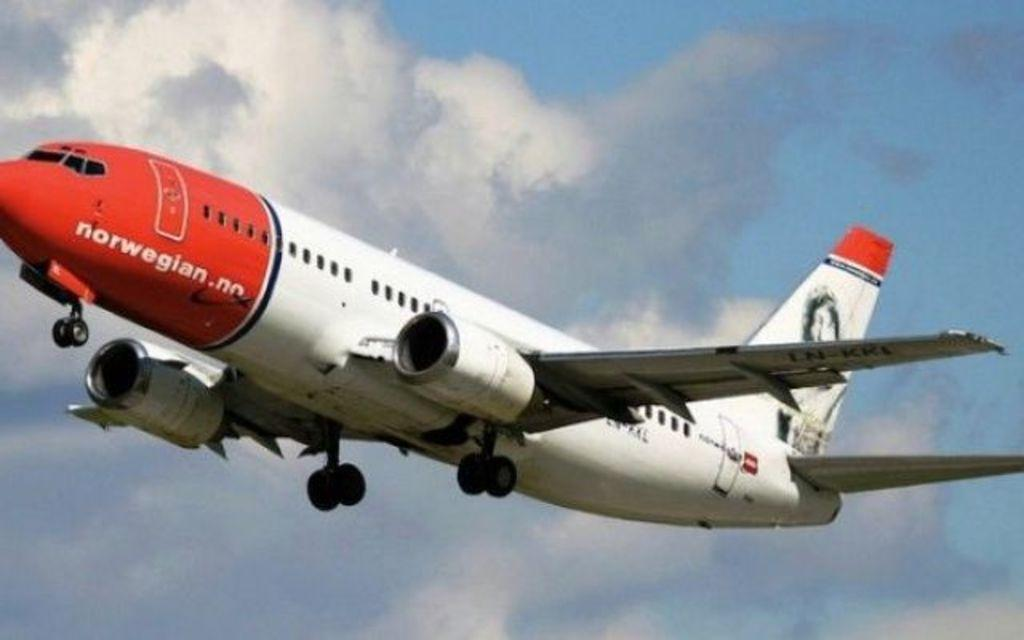Where was the picture taken? The picture was clicked outside. What can be seen in the sky in the image? Answers: There is an airplane flying in the sky. What is visible in the background of the image? The sky is visible in the background. Are there any weather conditions indicated in the image? Yes, clouds are present in the sky. What type of bun is being used as a cushion for the airplane in the image? There is no bun or cushion present in the image; it features an airplane flying in the sky. Can you tell me how many alleys are visible in the image? There are no alleys visible in the image; it was taken outside with a focus on the sky and an airplane. 